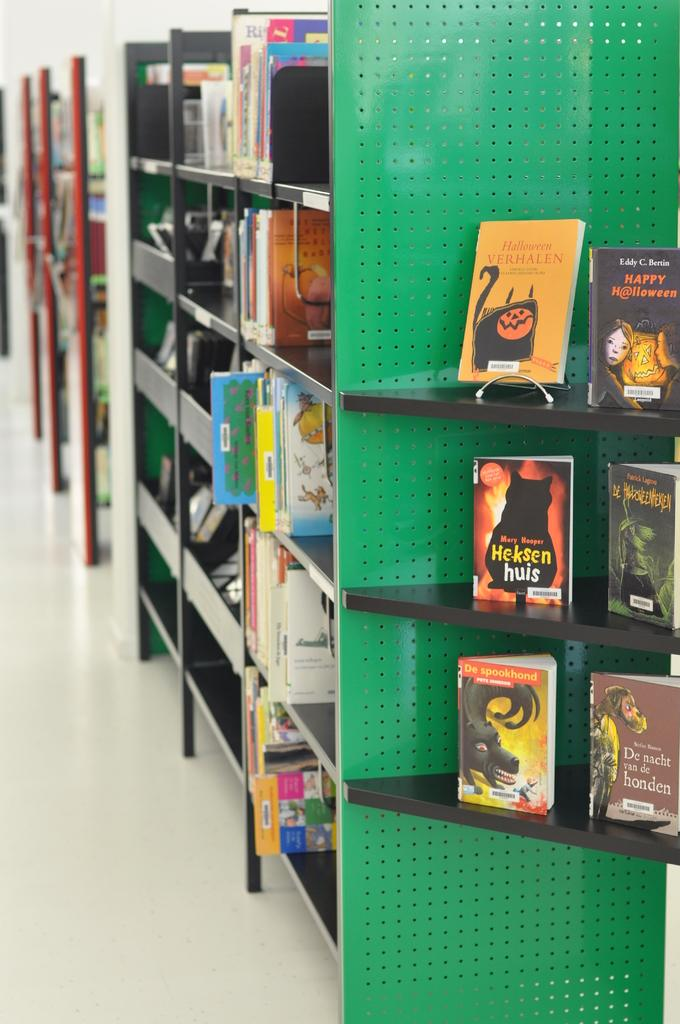<image>
Offer a succinct explanation of the picture presented. Halloween is printed as the title of several books in this display. 